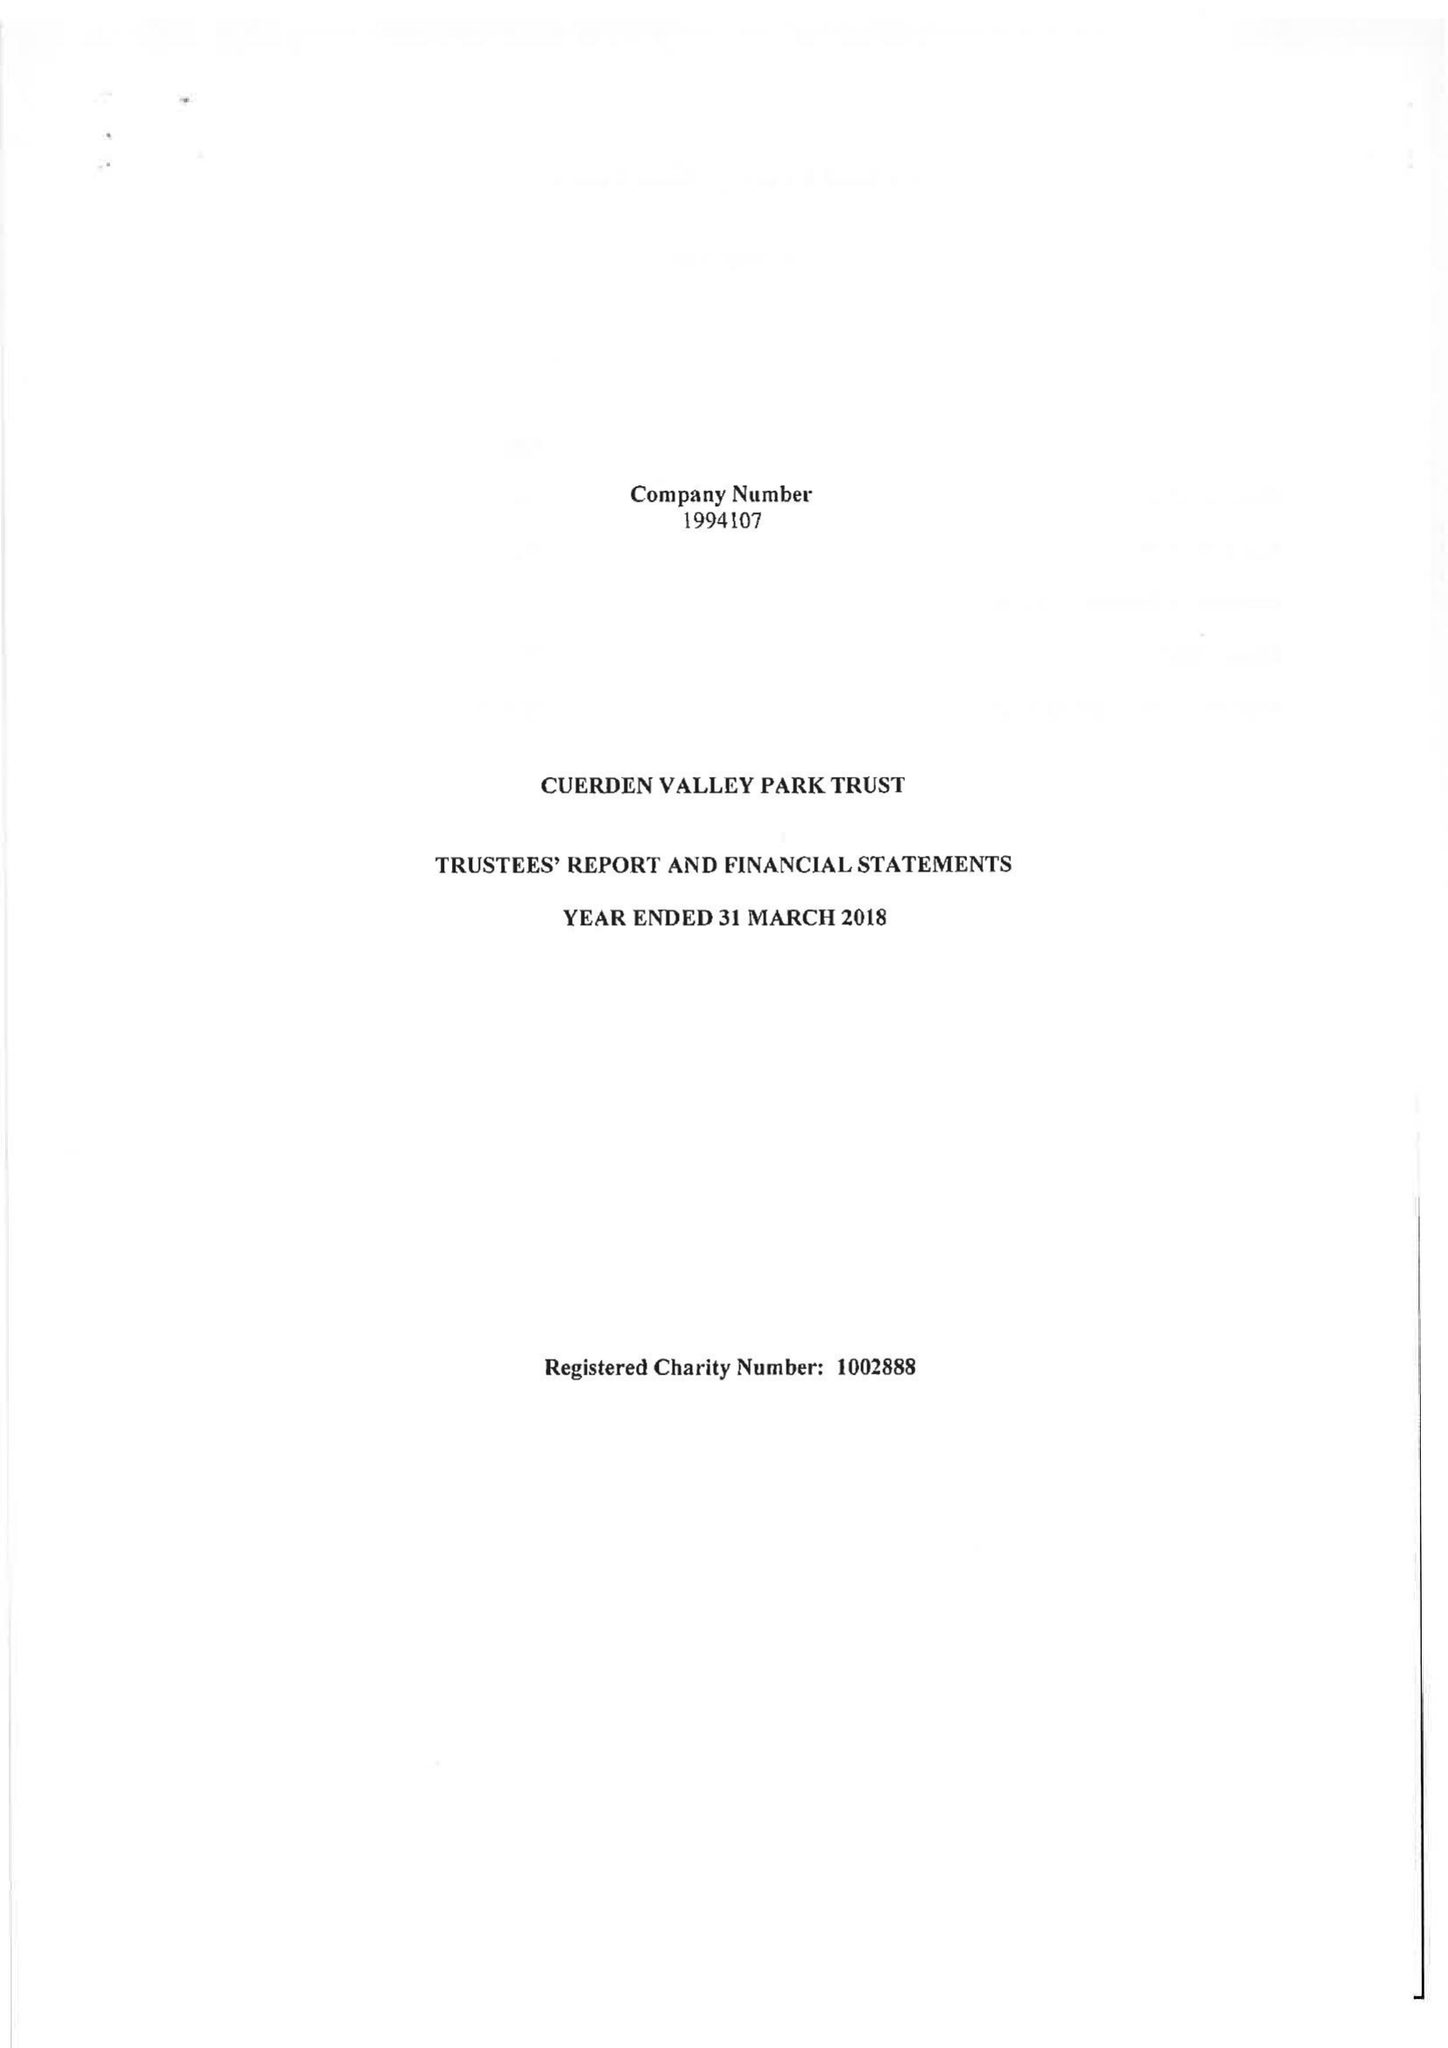What is the value for the address__post_town?
Answer the question using a single word or phrase. PRESTON 